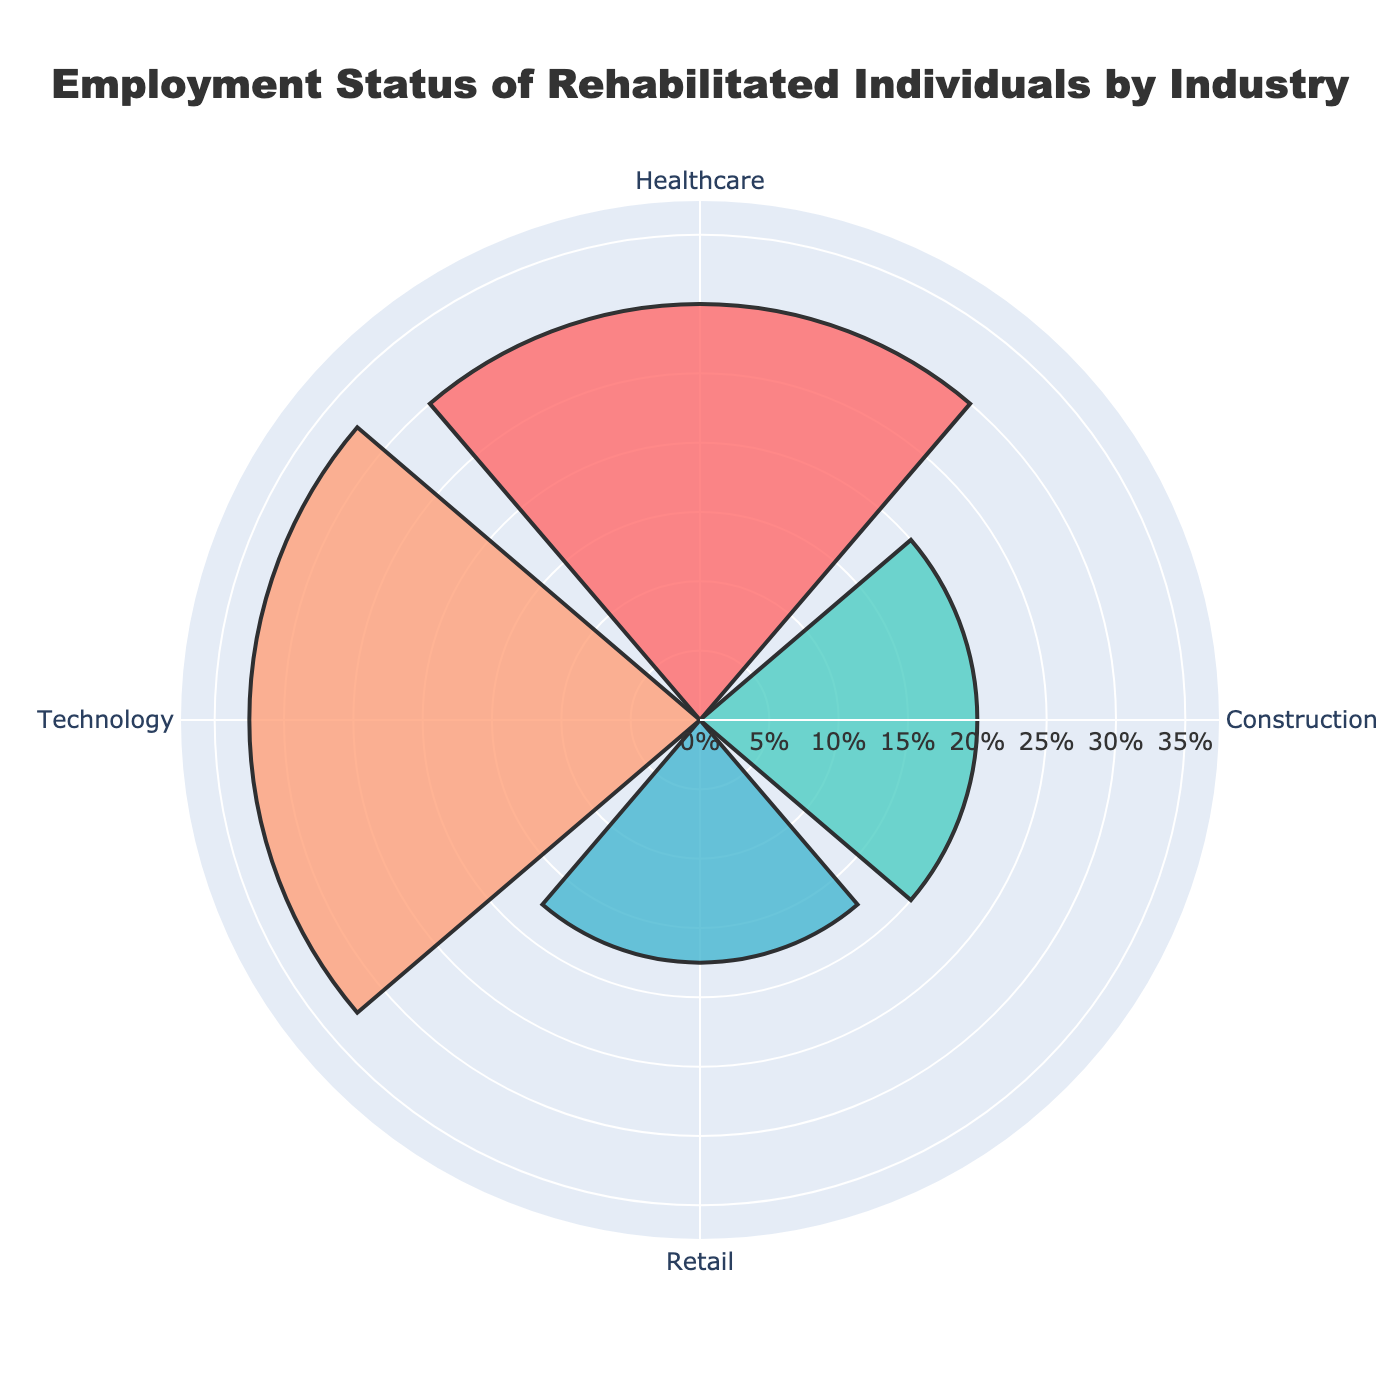What is the title of the figure? The title is displayed at the top of the figure in a large, bold font. It reads "Employment Status of Rehabilitated Individuals by Industry".
Answer: Employment Status of Rehabilitated Individuals by Industry Which industry has the highest percentage of rehabilitated individuals? From the bars on the rose chart, the longest bar corresponds to the Technology industry at 32.5%.
Answer: Technology What is the combined percentage of rehabilitated individuals in Healthcare and Retail industries? The percentage of Healthcare is 30% and Retail is 17.5%. Adding these together: 30% + 17.5% = 47.5%.
Answer: 47.5% How many data points are represented in the rose chart? Each segment of the rose chart represents a data point, and we can see there are four segments around the chart corresponding to the four industries.
Answer: 4 Which industry employs fewer rehabilitated individuals, Construction or Retail? Comparing the lengths of the segments, the Retail industry has a shorter segment compared to the Construction industry, which means it employs fewer individuals: 17.5% (Retail) vs 20% (Construction).
Answer: Retail What is the difference in the percentage of rehabilitated individuals between the Healthcare and Construction industries? The percentage for Healthcare is 30% and for Construction is 20%. The difference is 30% - 20% = 10%.
Answer: 10% What percentage of rehabilitated individuals is employed in industries other than Technology? The percentage for Technology is 32.5%. Subtracting from 100% gives us the percentage for all other industries: 100% - 32.5% = 67.5%.
Answer: 67.5% In which direction are the industries arranged around the rose chart? The title and layout of the chart indicate that the industries are arranged in a clockwise direction around the chart.
Answer: Clockwise What is the sum of the percentages of the Technology and Construction industries? Adding the percentages of Technology (32.5%) and Construction (20%), we get 32.5% + 20% = 52.5%.
Answer: 52.5% Is the percentage of rehabilitated individuals in Healthcare greater than in Retail? The Healthcare industry has a percentage of 30%, while Retail has 17.5%. Since 30% is greater than 17.5%, the Healthcare percentage is greater.
Answer: Yes 